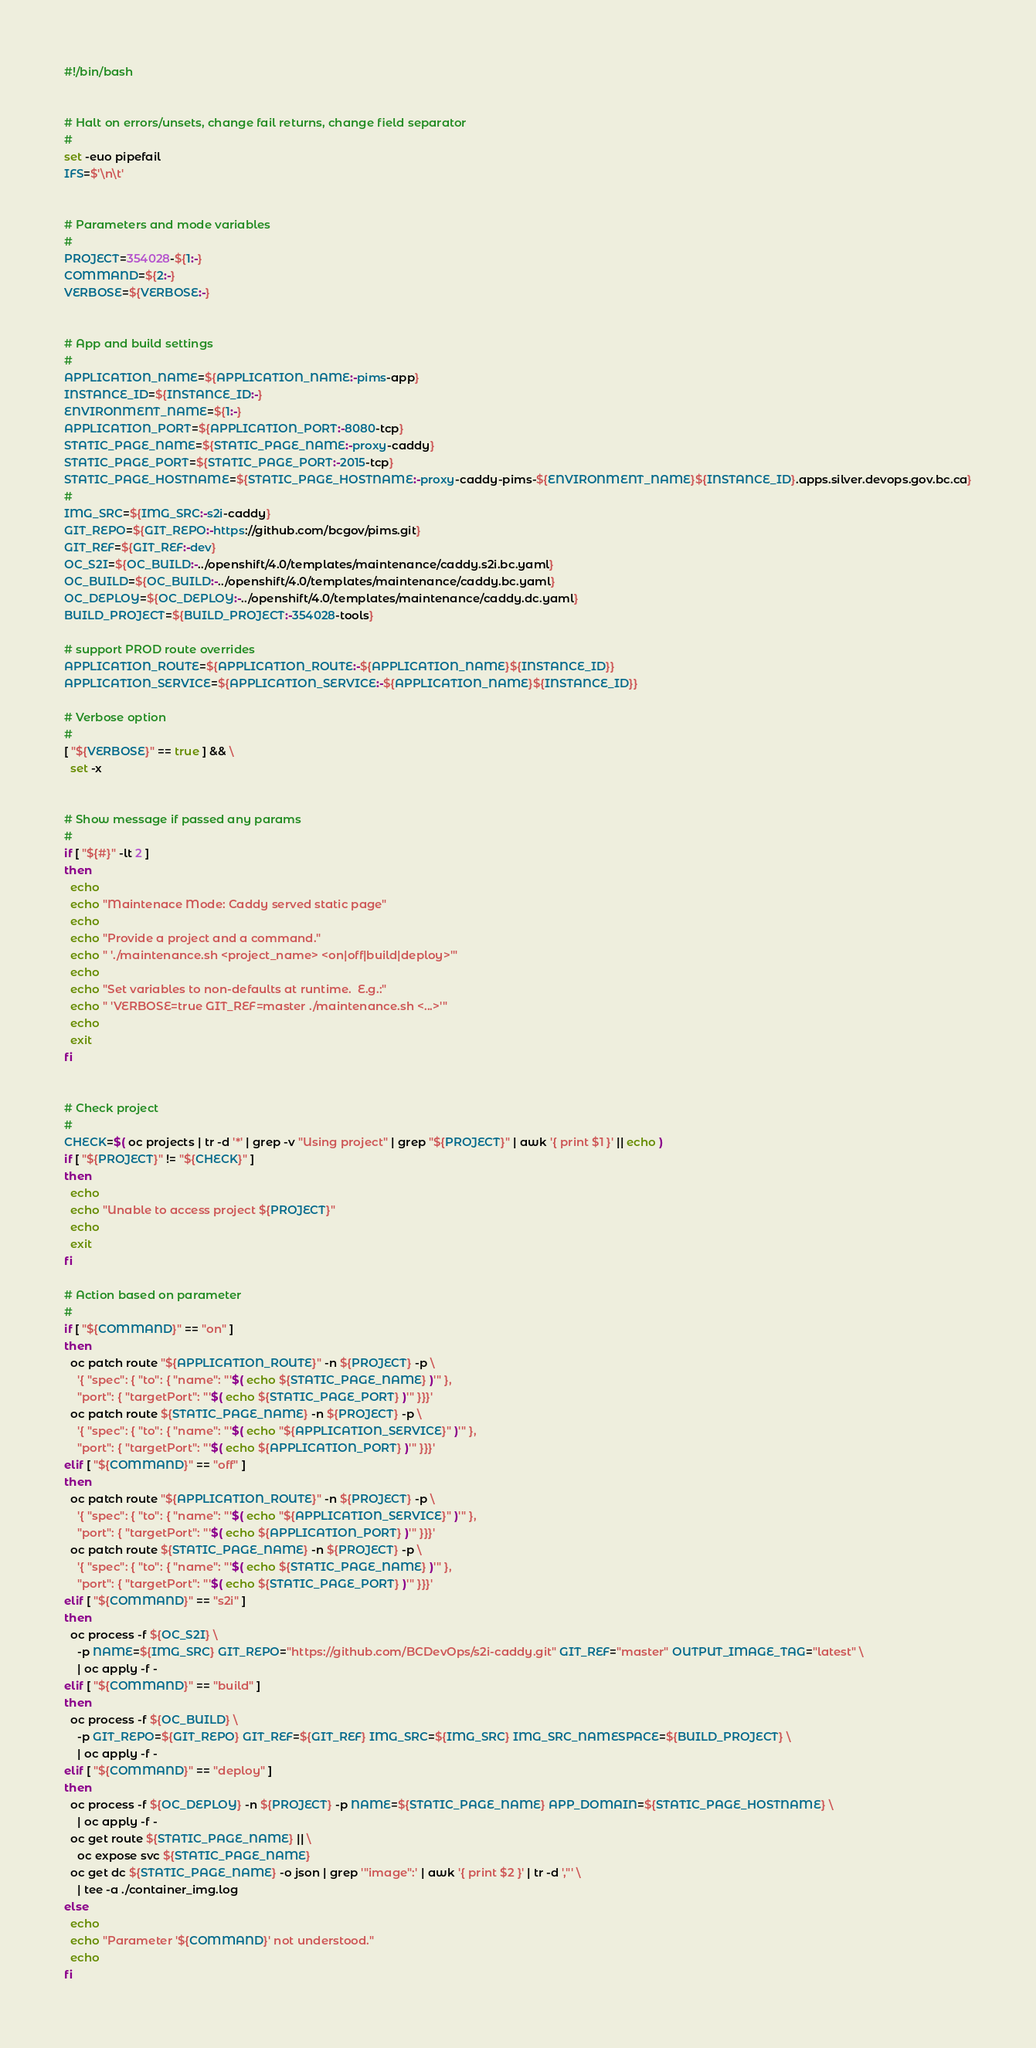<code> <loc_0><loc_0><loc_500><loc_500><_Bash_>#!/bin/bash


# Halt on errors/unsets, change fail returns, change field separator
#
set -euo pipefail
IFS=$'\n\t'


# Parameters and mode variables
#
PROJECT=354028-${1:-}
COMMAND=${2:-}
VERBOSE=${VERBOSE:-}


# App and build settings
#
APPLICATION_NAME=${APPLICATION_NAME:-pims-app}
INSTANCE_ID=${INSTANCE_ID:-}
ENVIRONMENT_NAME=${1:-}
APPLICATION_PORT=${APPLICATION_PORT:-8080-tcp}
STATIC_PAGE_NAME=${STATIC_PAGE_NAME:-proxy-caddy}
STATIC_PAGE_PORT=${STATIC_PAGE_PORT:-2015-tcp}
STATIC_PAGE_HOSTNAME=${STATIC_PAGE_HOSTNAME:-proxy-caddy-pims-${ENVIRONMENT_NAME}${INSTANCE_ID}.apps.silver.devops.gov.bc.ca}
#
IMG_SRC=${IMG_SRC:-s2i-caddy}
GIT_REPO=${GIT_REPO:-https://github.com/bcgov/pims.git}
GIT_REF=${GIT_REF:-dev}
OC_S2I=${OC_BUILD:-../openshift/4.0/templates/maintenance/caddy.s2i.bc.yaml}
OC_BUILD=${OC_BUILD:-../openshift/4.0/templates/maintenance/caddy.bc.yaml}
OC_DEPLOY=${OC_DEPLOY:-../openshift/4.0/templates/maintenance/caddy.dc.yaml}
BUILD_PROJECT=${BUILD_PROJECT:-354028-tools}

# support PROD route overrides
APPLICATION_ROUTE=${APPLICATION_ROUTE:-${APPLICATION_NAME}${INSTANCE_ID}}
APPLICATION_SERVICE=${APPLICATION_SERVICE:-${APPLICATION_NAME}${INSTANCE_ID}}

# Verbose option
#
[ "${VERBOSE}" == true ] && \
  set -x


# Show message if passed any params
#
if [ "${#}" -lt 2 ]
then
  echo
  echo "Maintenace Mode: Caddy served static page"
  echo
  echo "Provide a project and a command."
  echo " './maintenance.sh <project_name> <on|off|build|deploy>'"
  echo
  echo "Set variables to non-defaults at runtime.  E.g.:"
  echo " 'VERBOSE=true GIT_REF=master ./maintenance.sh <...>'"
  echo
  exit
fi


# Check project
#
CHECK=$( oc projects | tr -d '*' | grep -v "Using project" | grep "${PROJECT}" | awk '{ print $1 }' || echo )
if [ "${PROJECT}" != "${CHECK}" ]
then
  echo
  echo "Unable to access project ${PROJECT}"
  echo
  exit
fi

# Action based on parameter
#
if [ "${COMMAND}" == "on" ]
then
  oc patch route "${APPLICATION_ROUTE}" -n ${PROJECT} -p \
    '{ "spec": { "to": { "name": "'$( echo ${STATIC_PAGE_NAME} )'" },
    "port": { "targetPort": "'$( echo ${STATIC_PAGE_PORT} )'" }}}'
  oc patch route ${STATIC_PAGE_NAME} -n ${PROJECT} -p \
    '{ "spec": { "to": { "name": "'$( echo "${APPLICATION_SERVICE}" )'" },
    "port": { "targetPort": "'$( echo ${APPLICATION_PORT} )'" }}}'
elif [ "${COMMAND}" == "off" ]
then
  oc patch route "${APPLICATION_ROUTE}" -n ${PROJECT} -p \
    '{ "spec": { "to": { "name": "'$( echo "${APPLICATION_SERVICE}" )'" },
    "port": { "targetPort": "'$( echo ${APPLICATION_PORT} )'" }}}'
  oc patch route ${STATIC_PAGE_NAME} -n ${PROJECT} -p \
    '{ "spec": { "to": { "name": "'$( echo ${STATIC_PAGE_NAME} )'" },
    "port": { "targetPort": "'$( echo ${STATIC_PAGE_PORT} )'" }}}'
elif [ "${COMMAND}" == "s2i" ]
then
  oc process -f ${OC_S2I} \
    -p NAME=${IMG_SRC} GIT_REPO="https://github.com/BCDevOps/s2i-caddy.git" GIT_REF="master" OUTPUT_IMAGE_TAG="latest" \
    | oc apply -f -
elif [ "${COMMAND}" == "build" ]
then
  oc process -f ${OC_BUILD} \
    -p GIT_REPO=${GIT_REPO} GIT_REF=${GIT_REF} IMG_SRC=${IMG_SRC} IMG_SRC_NAMESPACE=${BUILD_PROJECT} \
    | oc apply -f -
elif [ "${COMMAND}" == "deploy" ]
then
  oc process -f ${OC_DEPLOY} -n ${PROJECT} -p NAME=${STATIC_PAGE_NAME} APP_DOMAIN=${STATIC_PAGE_HOSTNAME} \
    | oc apply -f -
  oc get route ${STATIC_PAGE_NAME} || \
    oc expose svc ${STATIC_PAGE_NAME}
  oc get dc ${STATIC_PAGE_NAME} -o json | grep '"image":' | awk '{ print $2 }' | tr -d ',"' \
    | tee -a ./container_img.log
else
  echo
  echo "Parameter '${COMMAND}' not understood."
  echo
fi
</code> 